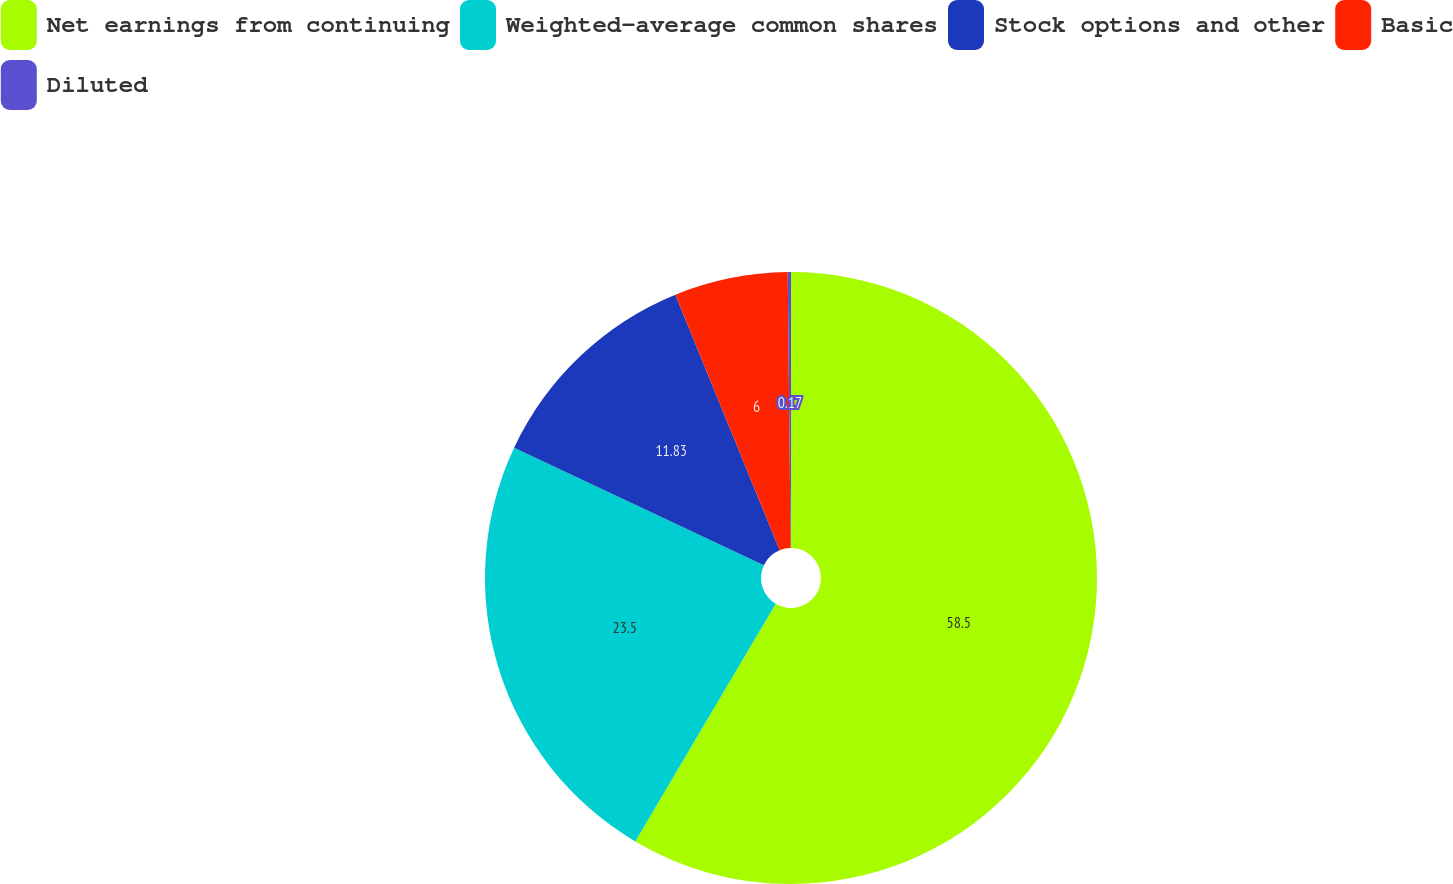Convert chart. <chart><loc_0><loc_0><loc_500><loc_500><pie_chart><fcel>Net earnings from continuing<fcel>Weighted-average common shares<fcel>Stock options and other<fcel>Basic<fcel>Diluted<nl><fcel>58.5%<fcel>23.5%<fcel>11.83%<fcel>6.0%<fcel>0.17%<nl></chart> 